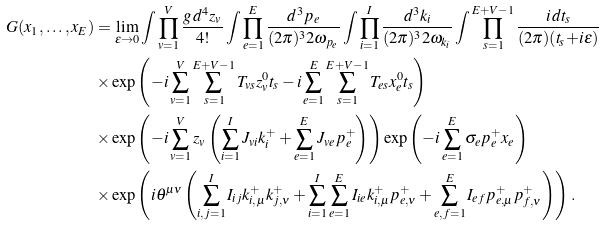Convert formula to latex. <formula><loc_0><loc_0><loc_500><loc_500>G ( x _ { 1 } , \dots , x _ { E } ) & = \lim _ { \epsilon \to 0 } \int \prod _ { v = 1 } ^ { V } \frac { g \, d ^ { 4 } z _ { v } } { 4 ! } \int \prod _ { e = 1 } ^ { E } \frac { d ^ { 3 } p _ { e } } { ( 2 \pi ) ^ { 3 } 2 \omega _ { p _ { e } } } \int \prod _ { i = 1 } ^ { I } \frac { d ^ { 3 } k _ { i } } { ( 2 \pi ) ^ { 3 } 2 \omega _ { k _ { i } } } \int \prod _ { s = 1 } ^ { E + V - 1 } \frac { i \, d t _ { s } } { ( 2 \pi ) ( t _ { s } { + } i \epsilon ) } \\ & \times \exp \left ( - i \sum _ { v = 1 } ^ { V } \sum _ { s = 1 } ^ { E + V - 1 } T _ { v s } z _ { v } ^ { 0 } t _ { s } - i \sum _ { e = 1 } ^ { E } \sum _ { s = 1 } ^ { E + V - 1 } T _ { e s } x _ { e } ^ { 0 } t _ { s } \right ) \\ & \times \exp \left ( - i \sum _ { v = 1 } ^ { V } z _ { v } \left ( \sum _ { i = 1 } ^ { I } J _ { v i } k _ { i } ^ { + } + \sum _ { e = 1 } ^ { E } J _ { v e } p _ { e } ^ { + } \right ) \right ) \exp \left ( - i \sum _ { e = 1 } ^ { E } \sigma _ { e } p _ { e } ^ { + } x _ { e } \right ) \\ & \times \exp \left ( i \theta ^ { \mu \nu } \left ( \sum _ { i , j = 1 } ^ { I } I _ { i j } k _ { i , \mu } ^ { + } k _ { j , \nu } ^ { + } + \sum _ { i = 1 } ^ { I } \sum _ { e = 1 } ^ { E } I _ { i e } k _ { i , \mu } ^ { + } p _ { e , \nu } ^ { + } + \sum _ { e , f = 1 } ^ { E } I _ { e f } p _ { e , \mu } ^ { + } p _ { f , \nu } ^ { + } \right ) \right ) \, .</formula> 